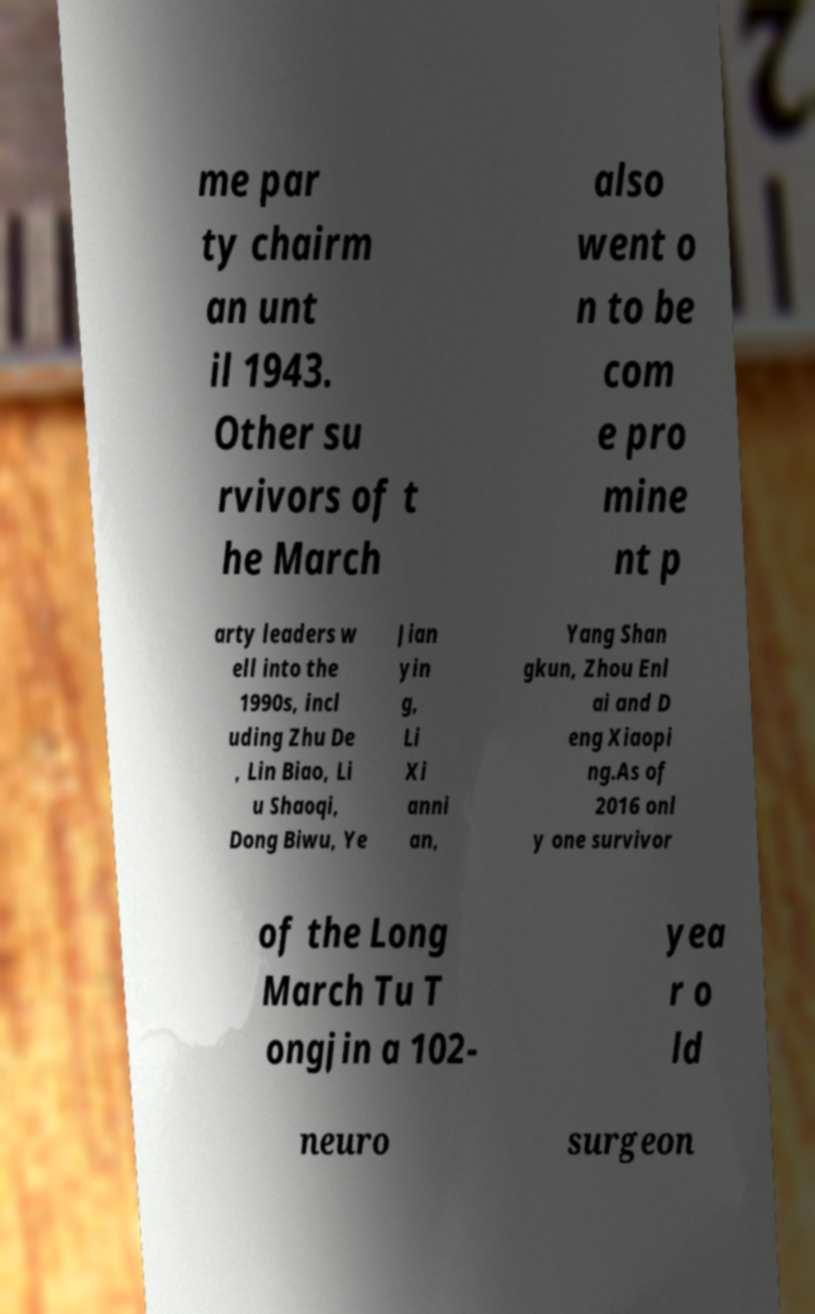Can you accurately transcribe the text from the provided image for me? me par ty chairm an unt il 1943. Other su rvivors of t he March also went o n to be com e pro mine nt p arty leaders w ell into the 1990s, incl uding Zhu De , Lin Biao, Li u Shaoqi, Dong Biwu, Ye Jian yin g, Li Xi anni an, Yang Shan gkun, Zhou Enl ai and D eng Xiaopi ng.As of 2016 onl y one survivor of the Long March Tu T ongjin a 102- yea r o ld neuro surgeon 